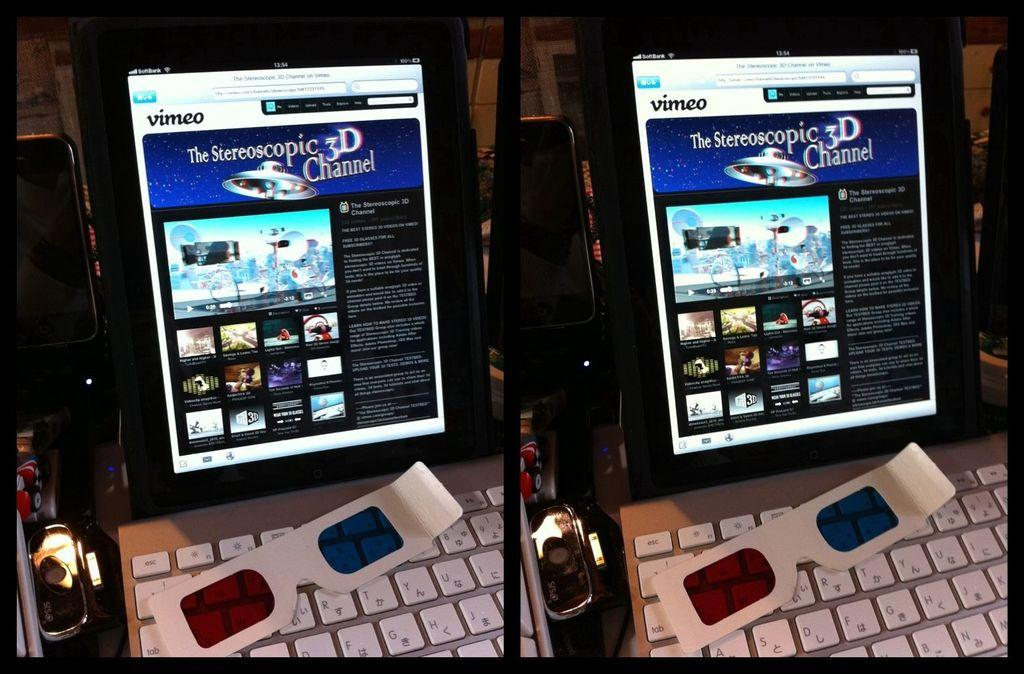<image>
Present a compact description of the photo's key features. A tablet screen has Vimeo pulled up on it. 